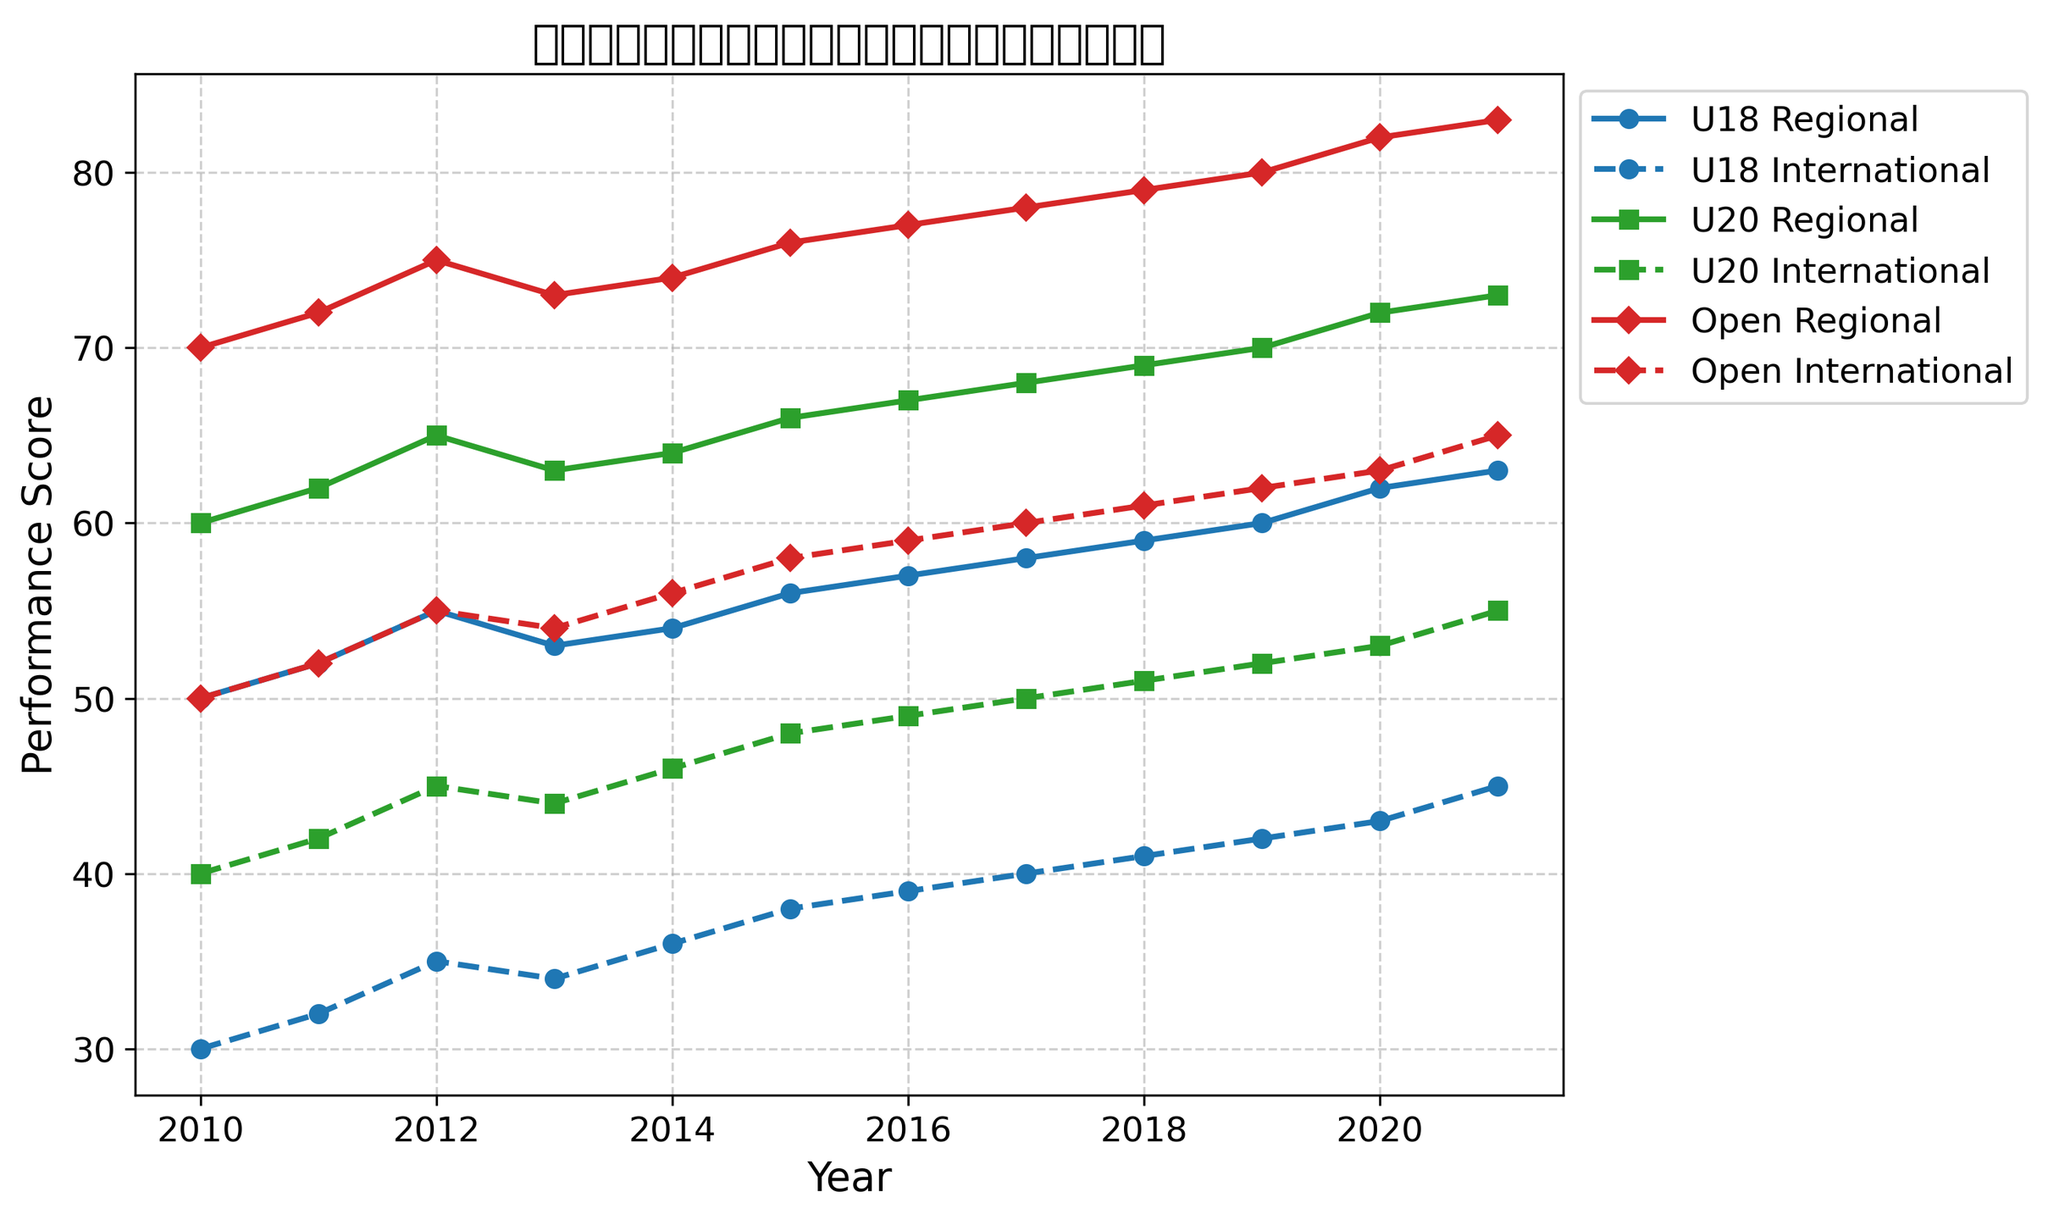Which age group shows the highest regional performance in 2021? To find the highest regional performance in 2021, we check the 2021 performance scores for U18, U20, and Open age groups. The scores are: U18 (63), U20 (73), and Open (83). The Open age group has the highest score.
Answer: Open Which age group has the most significant improvement in regional performance from 2010 to 2021? Calculate the difference between 2021 and 2010 performance scores for each age group: 
U18: 63 - 50 = 13, 
U20: 73 - 60 = 13, 
Open: 83 - 70 = 13. 
All groups have the same improvement.
Answer: All age groups What is the difference in international performance scores between the U20 and Open age groups in 2015? Compare the international performance scores in 2015 for U20 and Open age groups. U20 is 48, Open is 58. The difference is 58 - 48.
Answer: 10 Which age group showed the least change in international performance from 2013 to 2014? Calculate the change in international performance from 2013 to 2014 for each age group: 
U18: 36 - 34 = 2, 
U20: 46 - 44 = 2, 
Open: 56 - 54 = 2. 
All groups showed the same change.
Answer: All age groups In which year did the U18 age group show the same regional performance score as the U20's international performance score? Determine the years where U18's regional scores match U20's international scores:
- U18 2017 regional performance: 58
- U20 2017 international performance: 50.
So, the matching year is 2017.
Answer: None How does the regional performance trend for the Open group change over the years? Observe year-by-year changes for Open group’s regional performance from 2010 to 2021. It generally increases almost every year.
Answer: Increasing Which year saw the highest international performance score for the U18 age group? Look for the highest international performance score for U18 across all years: The scores increase each year, peaking in 2021 at 45.
Answer: 2021 Compare the regional performance trends between U18 and U20 groups. Both the U18 and U20 groups show a generally increasing trend in regional performance from 2010 to 2021. U18 ranges from 50 to 63, U20 from 60 to 73.
Answer: Both increase In 2015, how much higher is the regional performance of the Open group compared to the U18 group? Check the regional scores of groups in 2015: U18 (56) and Open (76). The difference is 76 - 56.
Answer: 20 